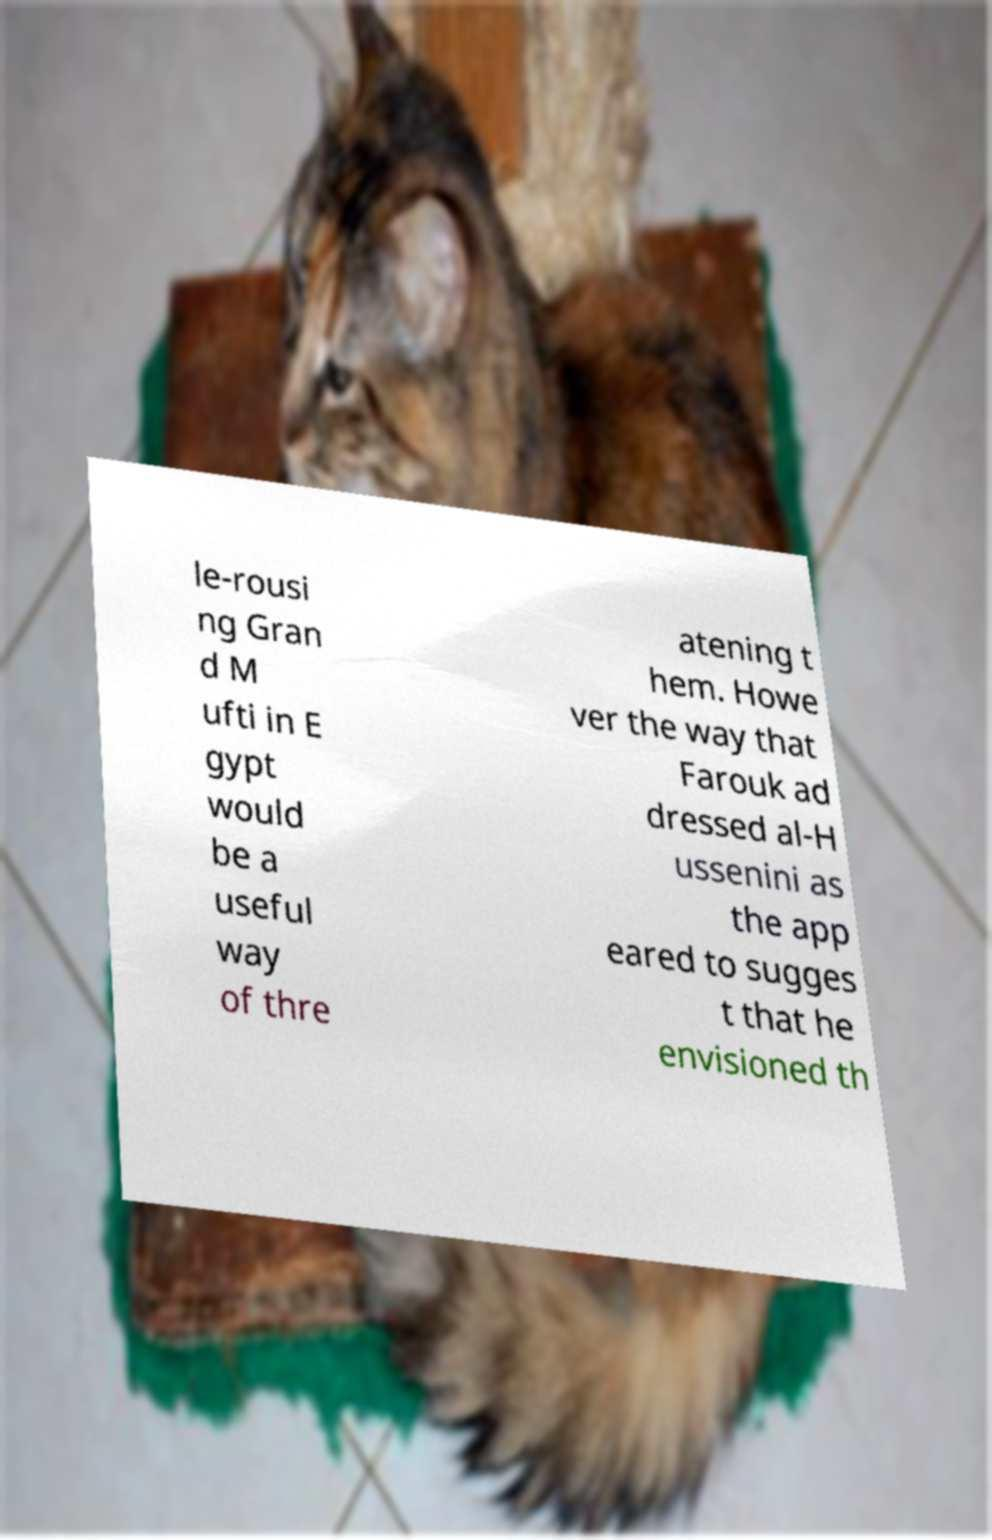Could you assist in decoding the text presented in this image and type it out clearly? le-rousi ng Gran d M ufti in E gypt would be a useful way of thre atening t hem. Howe ver the way that Farouk ad dressed al-H ussenini as the app eared to sugges t that he envisioned th 